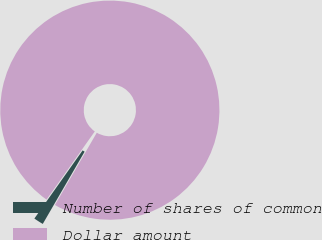Convert chart. <chart><loc_0><loc_0><loc_500><loc_500><pie_chart><fcel>Number of shares of common<fcel>Dollar amount<nl><fcel>1.45%<fcel>98.55%<nl></chart> 